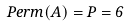<formula> <loc_0><loc_0><loc_500><loc_500>P e r m ( A ) = P = 6</formula> 